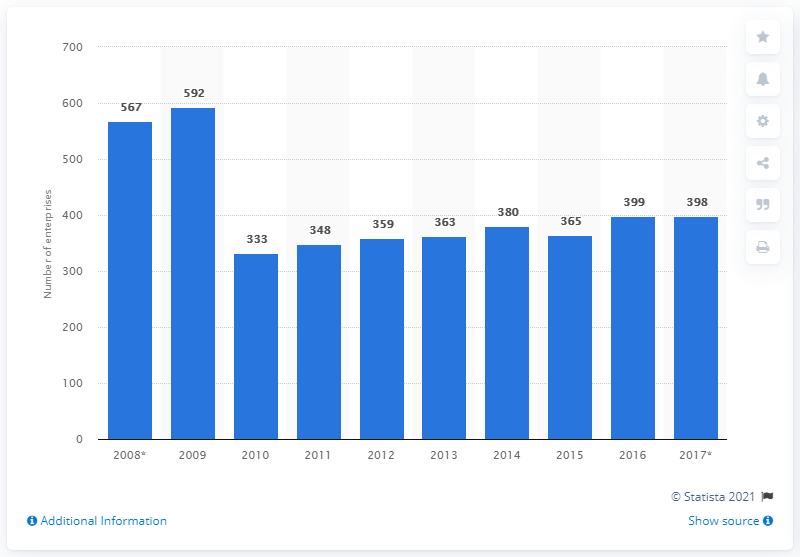Highlight a few significant elements in this photo. In 2017, there were 398 mining and quarrying enterprises operating in the Czech Republic. 